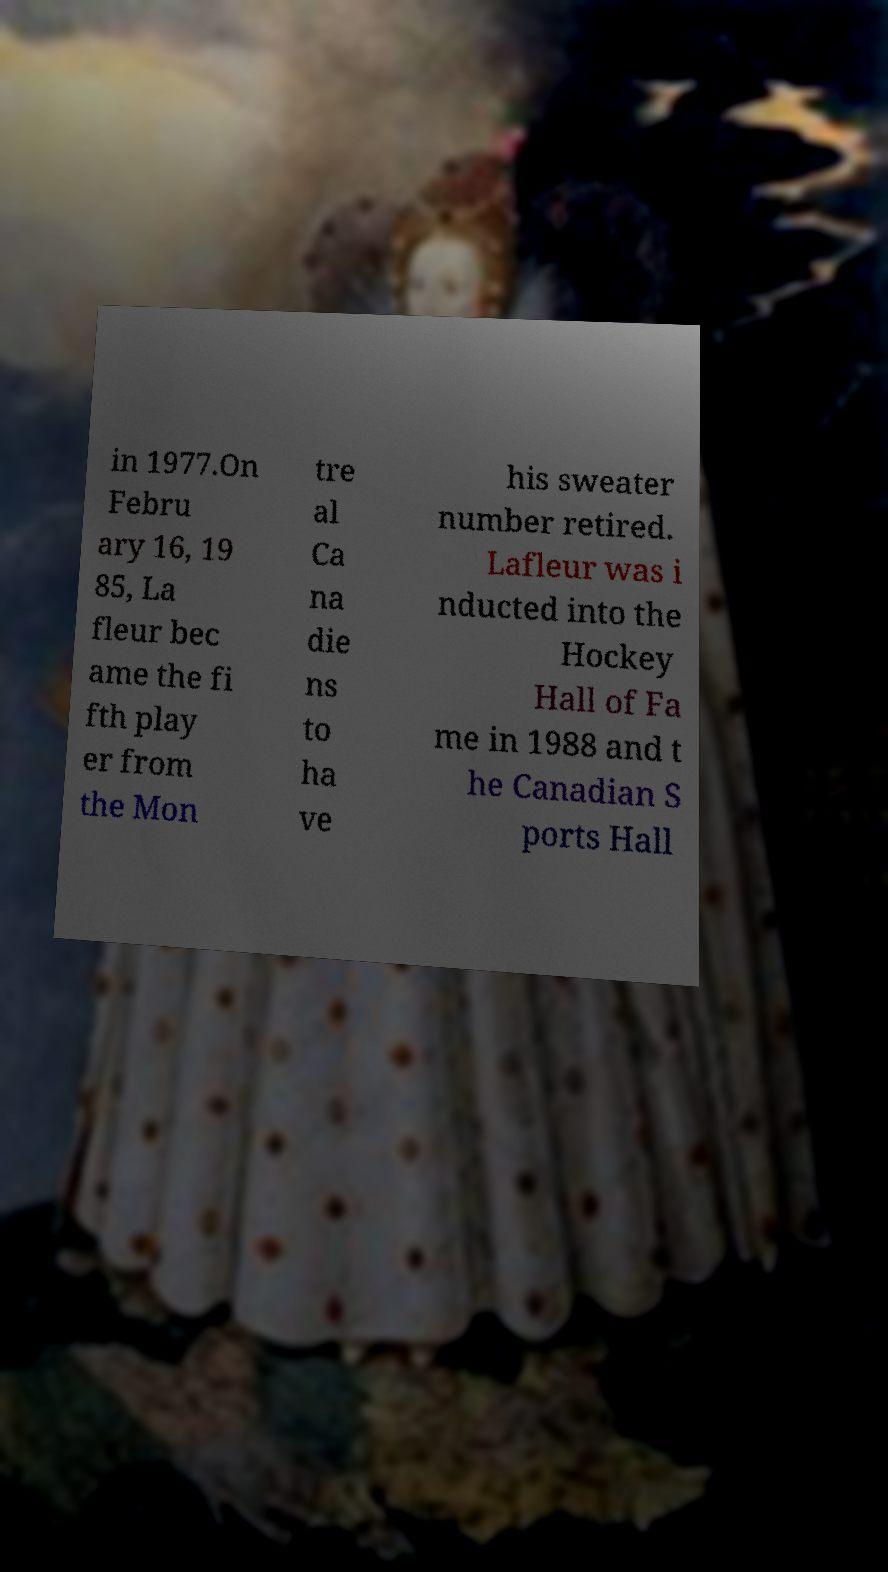Please identify and transcribe the text found in this image. in 1977.On Febru ary 16, 19 85, La fleur bec ame the fi fth play er from the Mon tre al Ca na die ns to ha ve his sweater number retired. Lafleur was i nducted into the Hockey Hall of Fa me in 1988 and t he Canadian S ports Hall 